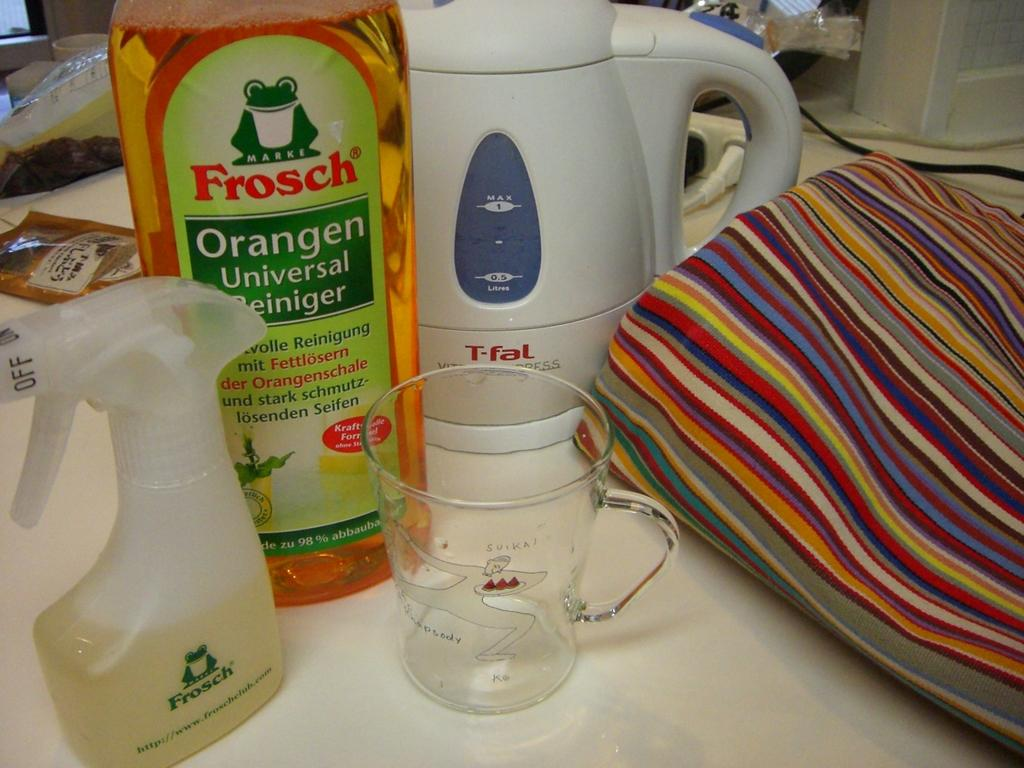<image>
Write a terse but informative summary of the picture. A couple of cleaning products from Frosch lie on a table. 